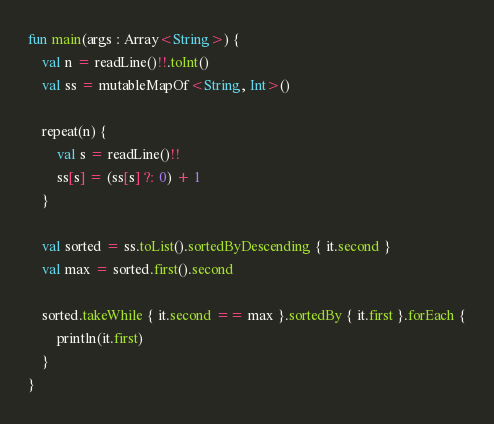<code> <loc_0><loc_0><loc_500><loc_500><_Kotlin_>fun main(args : Array<String>) {
    val n = readLine()!!.toInt()
    val ss = mutableMapOf<String, Int>()

    repeat(n) {
        val s = readLine()!!
        ss[s] = (ss[s] ?: 0) + 1
    }

    val sorted = ss.toList().sortedByDescending { it.second }
    val max = sorted.first().second

    sorted.takeWhile { it.second == max }.sortedBy { it.first }.forEach {
        println(it.first)
    }
}</code> 